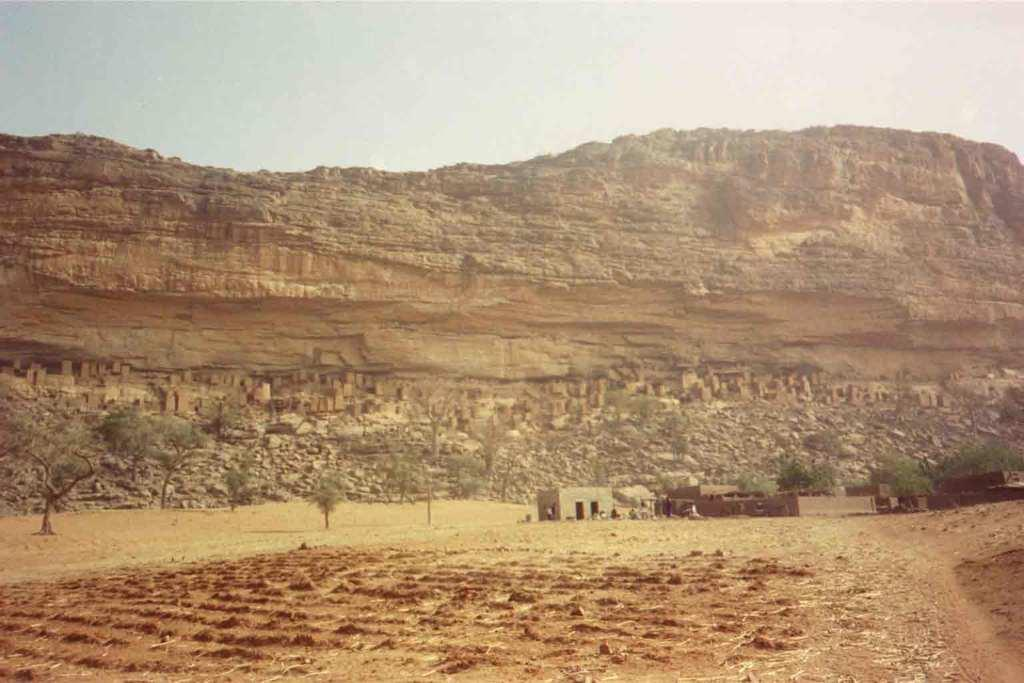What can be seen in the foreground of the image? There is empty land in the foreground of the image. What type of vegetation is present in the image? There are trees in the image. Are there any structures visible in the image? It appears there are houses in the image. What type of natural feature can be seen in the image? There are stones in the image. What is visible in the background of the image? There is a huge hill and the sky in the background of the image. How many teeth can be seen in the image? There are no teeth visible in the image. What type of animals are grazing on the hill in the image? There are no animals present in the image, so it is not possible to determine what type of animals might be grazing on the hill. 